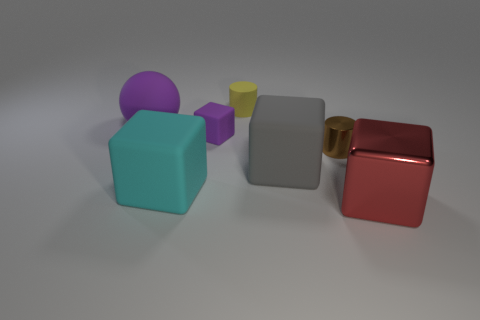Subtract all large red blocks. How many blocks are left? 3 Subtract all red blocks. How many blocks are left? 3 Add 3 yellow spheres. How many objects exist? 10 Subtract all red cubes. Subtract all gray balls. How many cubes are left? 3 Subtract all balls. How many objects are left? 6 Subtract all gray objects. Subtract all gray matte blocks. How many objects are left? 5 Add 4 yellow rubber things. How many yellow rubber things are left? 5 Add 5 large blocks. How many large blocks exist? 8 Subtract 0 yellow balls. How many objects are left? 7 